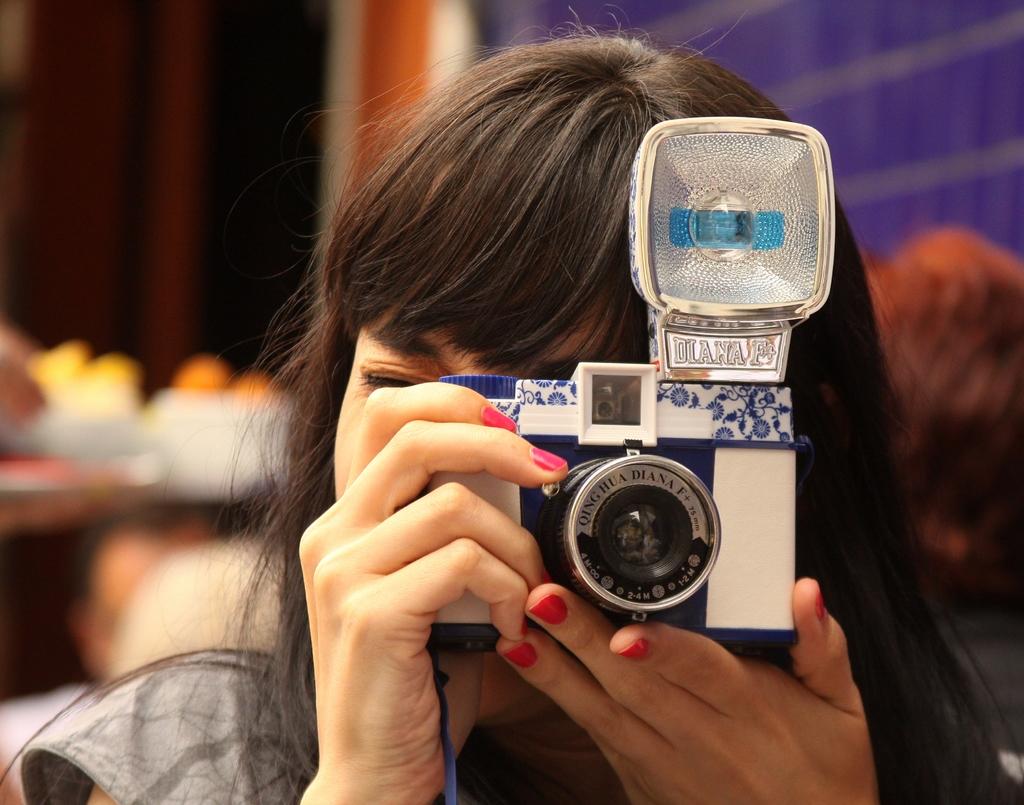What type of camera is that?
Provide a succinct answer. Diana f+. What name is written under the flash?
Your response must be concise. Diana f. 